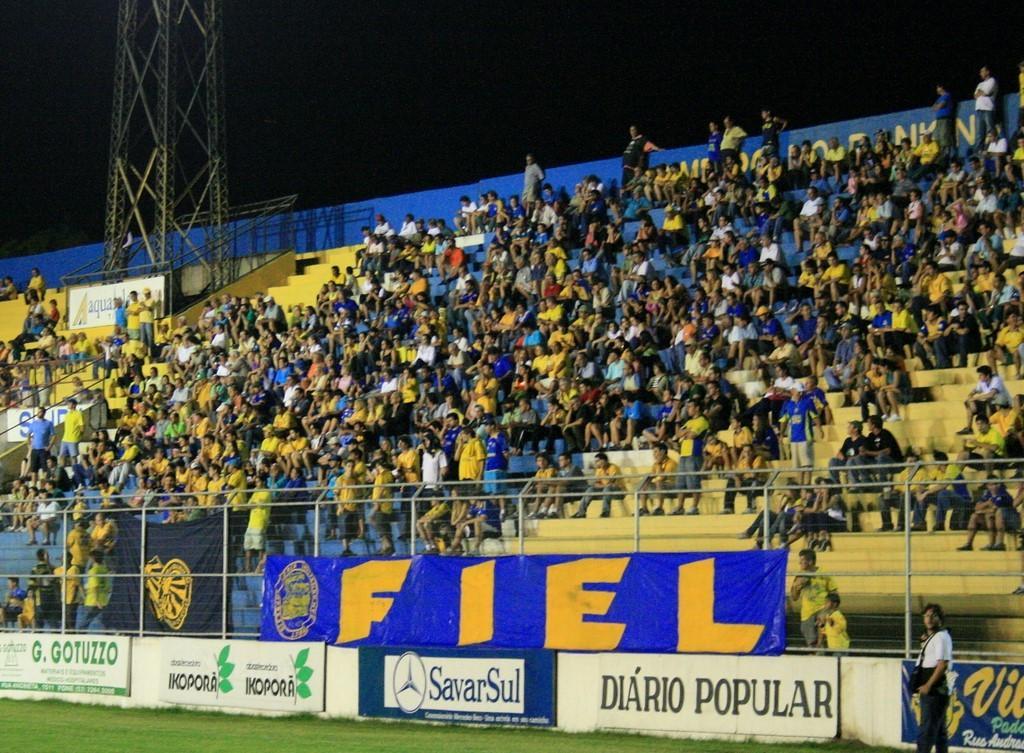In one or two sentences, can you explain what this image depicts? In this image I can see the group of people, few people are sitting and few people are standing. I can see boards, fencing, banners, metal tower, stairs and the black color background. 